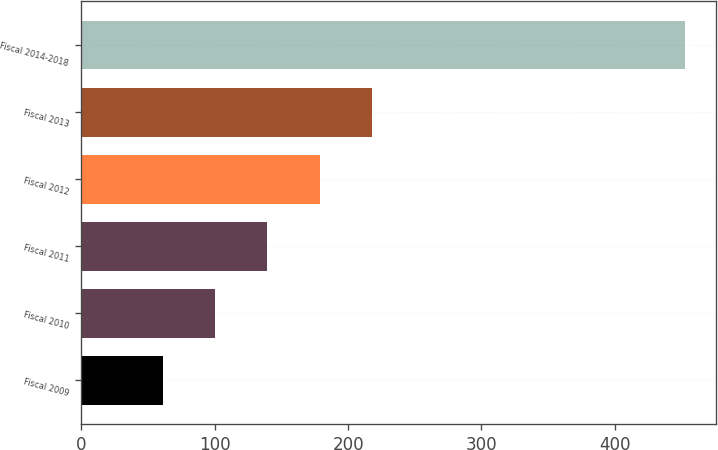Convert chart to OTSL. <chart><loc_0><loc_0><loc_500><loc_500><bar_chart><fcel>Fiscal 2009<fcel>Fiscal 2010<fcel>Fiscal 2011<fcel>Fiscal 2012<fcel>Fiscal 2013<fcel>Fiscal 2014-2018<nl><fcel>61<fcel>100.2<fcel>139.4<fcel>178.6<fcel>217.8<fcel>453<nl></chart> 